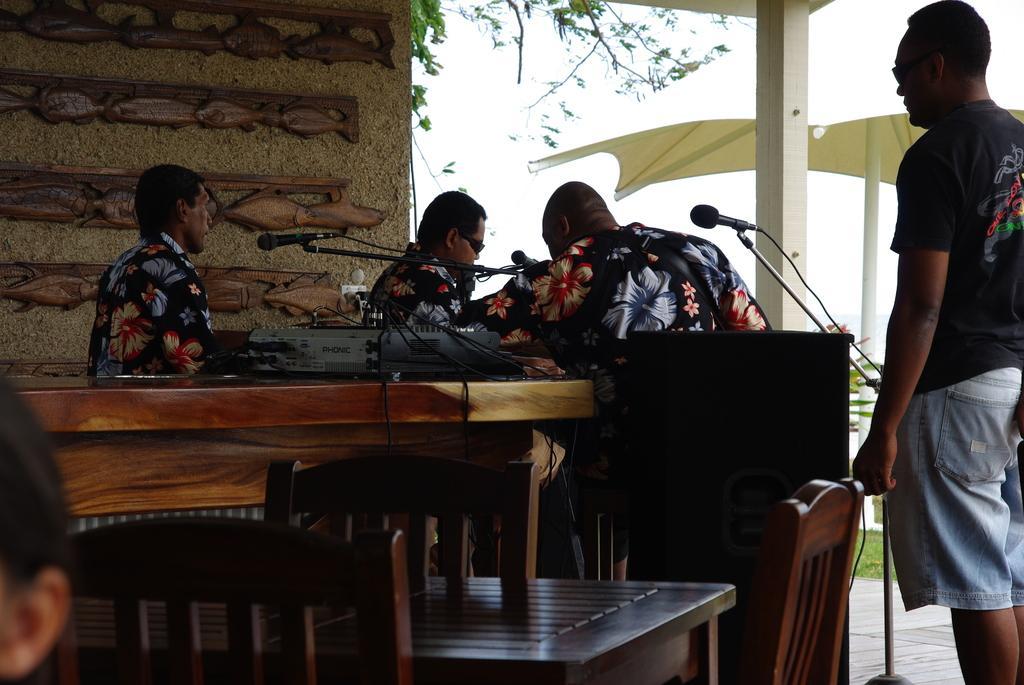Please provide a concise description of this image. In this picture we can see four men where three are sitting and one is standing and in front of them we have mics, machine on table and in background we can see wall, trees, sky, sun shade. 